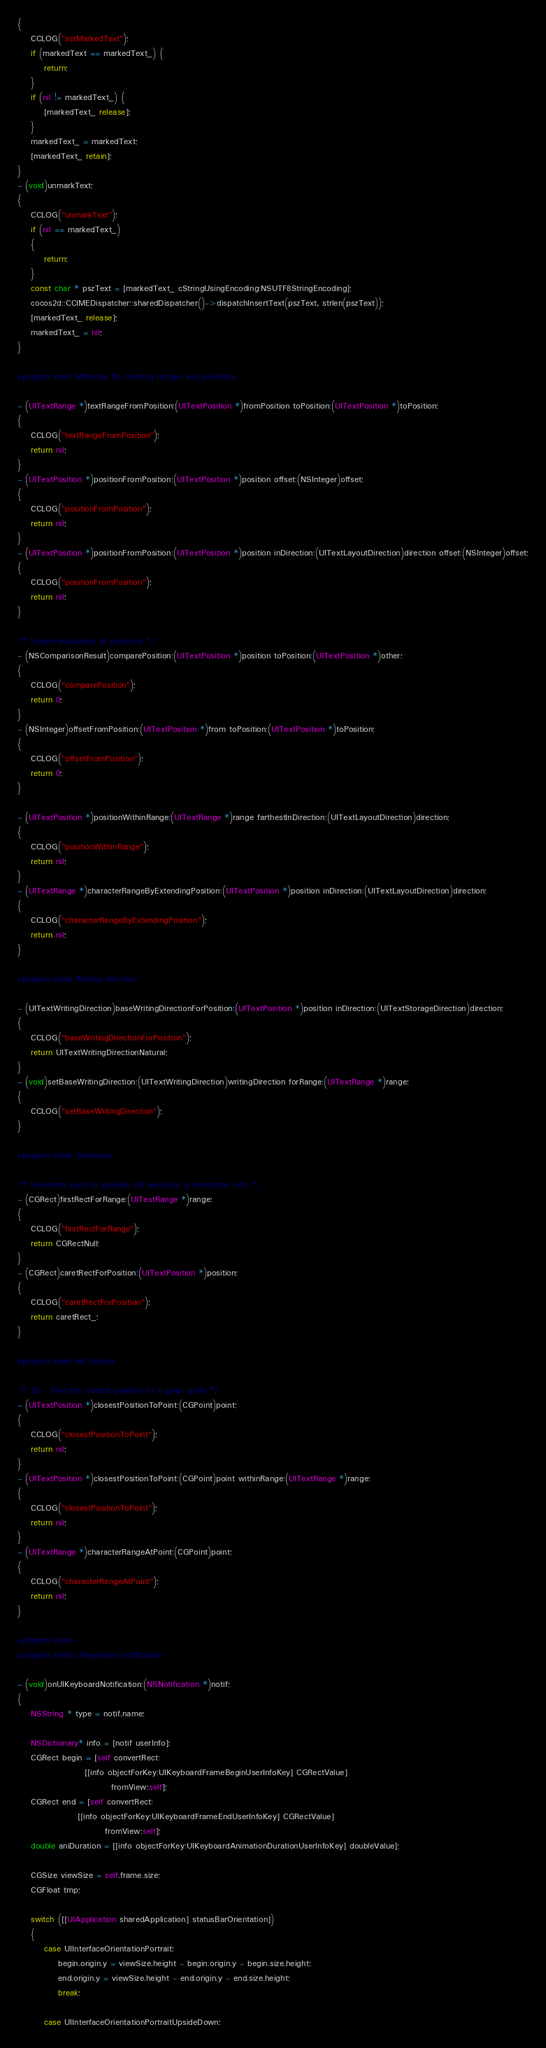<code> <loc_0><loc_0><loc_500><loc_500><_ObjectiveC_>{
    CCLOG("setMarkedText");
	if (markedText == markedText_) {
		return;
	}
	if (nil != markedText_) {
		[markedText_ release];
	}
    markedText_ = markedText;
	[markedText_ retain];
}
- (void)unmarkText;
{
    CCLOG("unmarkText");
    if (nil == markedText_)
    {
        return;
    }
    const char * pszText = [markedText_ cStringUsingEncoding:NSUTF8StringEncoding];
    cocos2d::CCIMEDispatcher::sharedDispatcher()->dispatchInsertText(pszText, strlen(pszText));
	[markedText_ release];
    markedText_ = nil;
}

#pragma mark Methods for creating ranges and positions.

- (UITextRange *)textRangeFromPosition:(UITextPosition *)fromPosition toPosition:(UITextPosition *)toPosition;
{
    CCLOG("textRangeFromPosition");
	return nil;
}
- (UITextPosition *)positionFromPosition:(UITextPosition *)position offset:(NSInteger)offset;
{
    CCLOG("positionFromPosition");
	return nil;
}
- (UITextPosition *)positionFromPosition:(UITextPosition *)position inDirection:(UITextLayoutDirection)direction offset:(NSInteger)offset;
{
    CCLOG("positionFromPosition");
	return nil;
}

/* Simple evaluation of positions */
- (NSComparisonResult)comparePosition:(UITextPosition *)position toPosition:(UITextPosition *)other;
{
    CCLOG("comparePosition");
	return 0;
}
- (NSInteger)offsetFromPosition:(UITextPosition *)from toPosition:(UITextPosition *)toPosition;
{
    CCLOG("offsetFromPosition");
	return 0;
}

- (UITextPosition *)positionWithinRange:(UITextRange *)range farthestInDirection:(UITextLayoutDirection)direction;
{
    CCLOG("positionWithinRange");
	return nil;
}
- (UITextRange *)characterRangeByExtendingPosition:(UITextPosition *)position inDirection:(UITextLayoutDirection)direction;
{
    CCLOG("characterRangeByExtendingPosition");
	return nil;
}

#pragma mark Writing direction

- (UITextWritingDirection)baseWritingDirectionForPosition:(UITextPosition *)position inDirection:(UITextStorageDirection)direction;
{
    CCLOG("baseWritingDirectionForPosition");
	return UITextWritingDirectionNatural;
}
- (void)setBaseWritingDirection:(UITextWritingDirection)writingDirection forRange:(UITextRange *)range;
{
    CCLOG("setBaseWritingDirection");
}

#pragma mark Geometry

/* Geometry used to provide, for example, a correction rect. */
- (CGRect)firstRectForRange:(UITextRange *)range;
{
    CCLOG("firstRectForRange");
	return CGRectNull;
}
- (CGRect)caretRectForPosition:(UITextPosition *)position;
{
	CCLOG("caretRectForPosition");
	return caretRect_;
}

#pragma mark Hit testing

/* JS - Find the closest position to a given point */
- (UITextPosition *)closestPositionToPoint:(CGPoint)point;
{
    CCLOG("closestPositionToPoint");
	return nil;
}
- (UITextPosition *)closestPositionToPoint:(CGPoint)point withinRange:(UITextRange *)range;
{
    CCLOG("closestPositionToPoint");
	return nil;
}
- (UITextRange *)characterRangeAtPoint:(CGPoint)point;
{
    CCLOG("characterRangeAtPoint");
	return nil;
}

#pragma mark -
#pragma mark UIKeyboard notification

- (void)onUIKeyboardNotification:(NSNotification *)notif;
{
    NSString * type = notif.name;
    
    NSDictionary* info = [notif userInfo];
    CGRect begin = [self convertRect: 
                    [[info objectForKey:UIKeyboardFrameBeginUserInfoKey] CGRectValue]
                            fromView:self];
    CGRect end = [self convertRect: 
                  [[info objectForKey:UIKeyboardFrameEndUserInfoKey] CGRectValue]
                          fromView:self];
    double aniDuration = [[info objectForKey:UIKeyboardAnimationDurationUserInfoKey] doubleValue];
    
    CGSize viewSize = self.frame.size;
    CGFloat tmp;
    
    switch ([[UIApplication sharedApplication] statusBarOrientation])
    {
        case UIInterfaceOrientationPortrait:
            begin.origin.y = viewSize.height - begin.origin.y - begin.size.height;
            end.origin.y = viewSize.height - end.origin.y - end.size.height;
            break;
            
        case UIInterfaceOrientationPortraitUpsideDown:</code> 